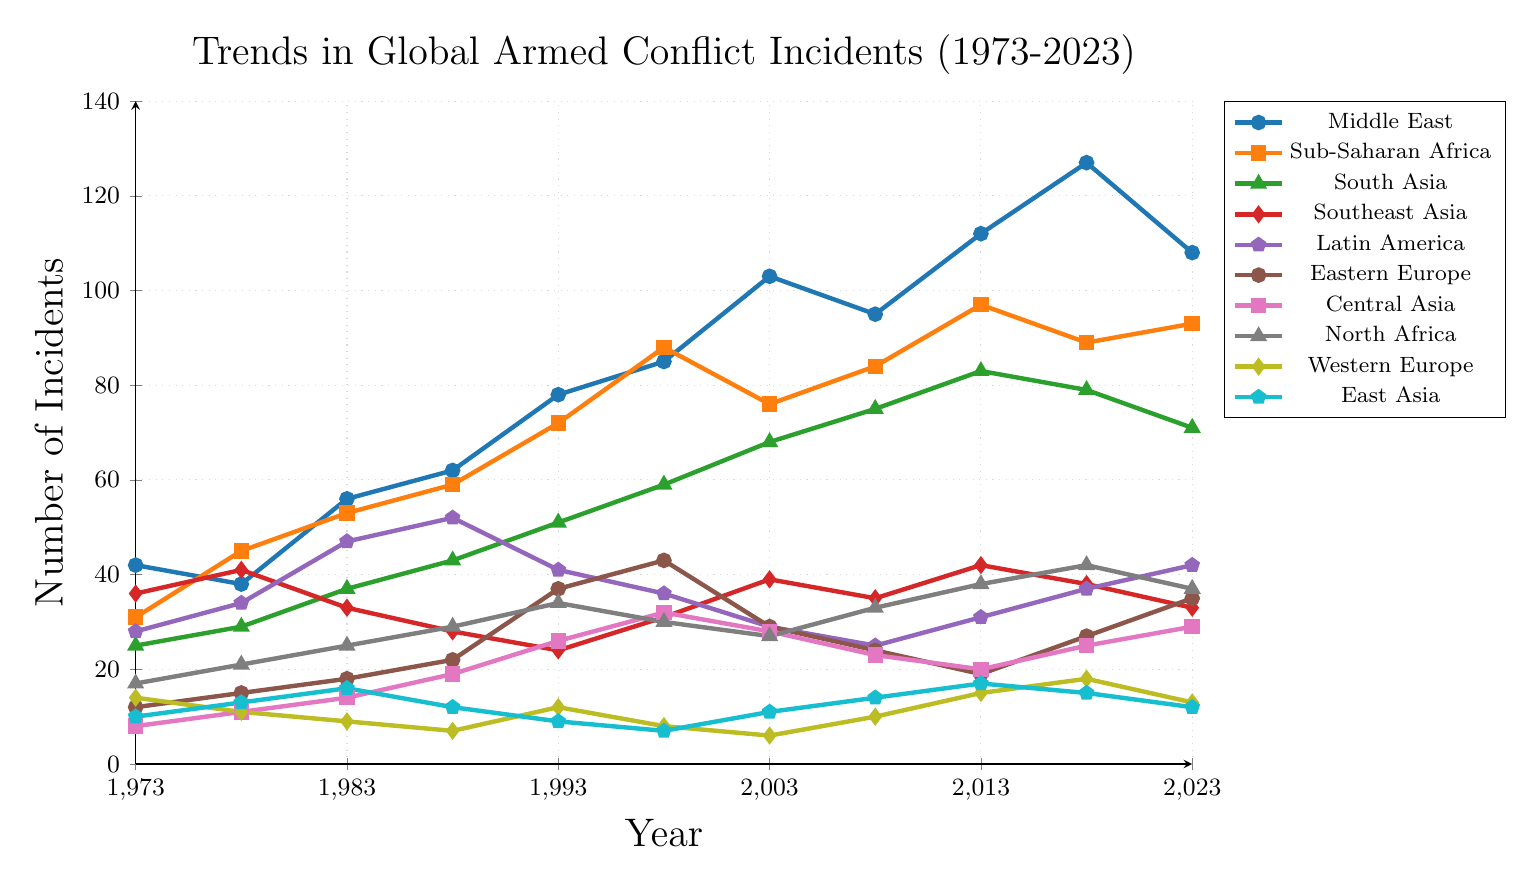Which region had the highest number of armed conflict incidents in 2023? To determine the region with the highest number of incidents in 2023, look at the endpoints of each line representing the different regions on the plot. The Middle East has the highest value at 108.
Answer: Middle East Between 1973 and 2023, which region saw the greatest increase in the number of incidents? To find the greatest increase, subtract the number of incidents in 1973 from the number in 2023 for each region. The Middle East increased from 42 to 108, which is an increase of 66, the highest among all regions.
Answer: Middle East In which year did South Asia have the greatest number of armed conflict incidents? Inspect the line representing South Asia and find the peak point. The highest value for South Asia is 83 incidents in 2013.
Answer: 2013 How did the trend in Western Europe compare to that of North Africa from 1993 to 2003? Check the values and trend lines for Western Europe and North Africa between 1993 and 2003. Western Europe declined from 12 to 6, while North Africa declined from 34 to 27, both showing a decreasing trend.
Answer: Both Declined What are the overall trends for Southeast Asia and Latin America from 1973 to 2023? Evaluate the trend lines for the two regions over time. Southeast Asia shows a decrease from 36 to 33, while Latin America shows an overall increase from 28 to 42.
Answer: Southeast Asia Decrease, Latin America Increase 